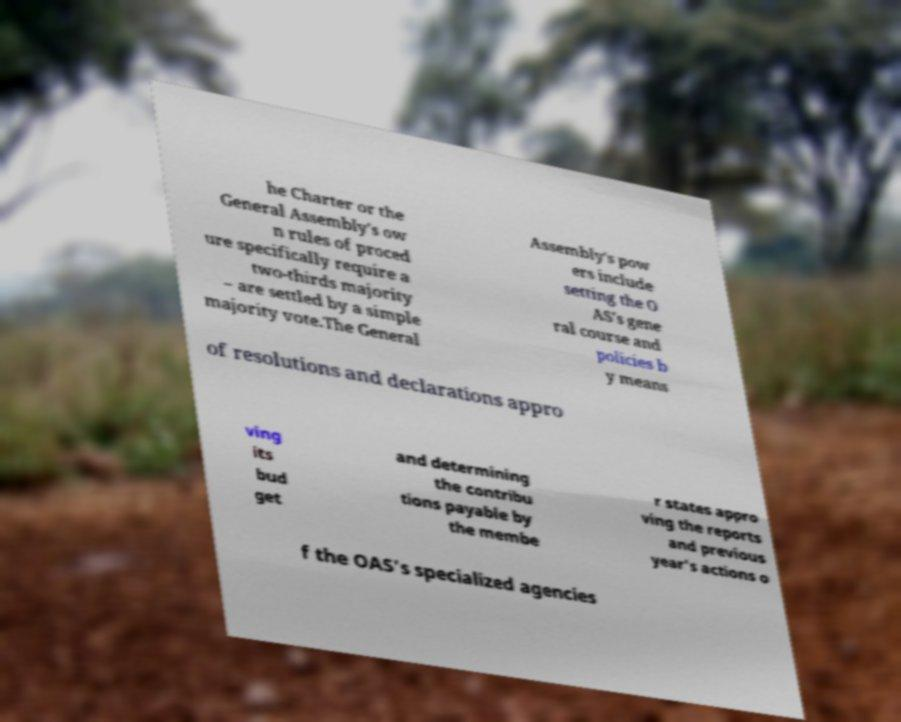For documentation purposes, I need the text within this image transcribed. Could you provide that? he Charter or the General Assembly's ow n rules of proced ure specifically require a two-thirds majority – are settled by a simple majority vote.The General Assembly's pow ers include setting the O AS's gene ral course and policies b y means of resolutions and declarations appro ving its bud get and determining the contribu tions payable by the membe r states appro ving the reports and previous year's actions o f the OAS's specialized agencies 